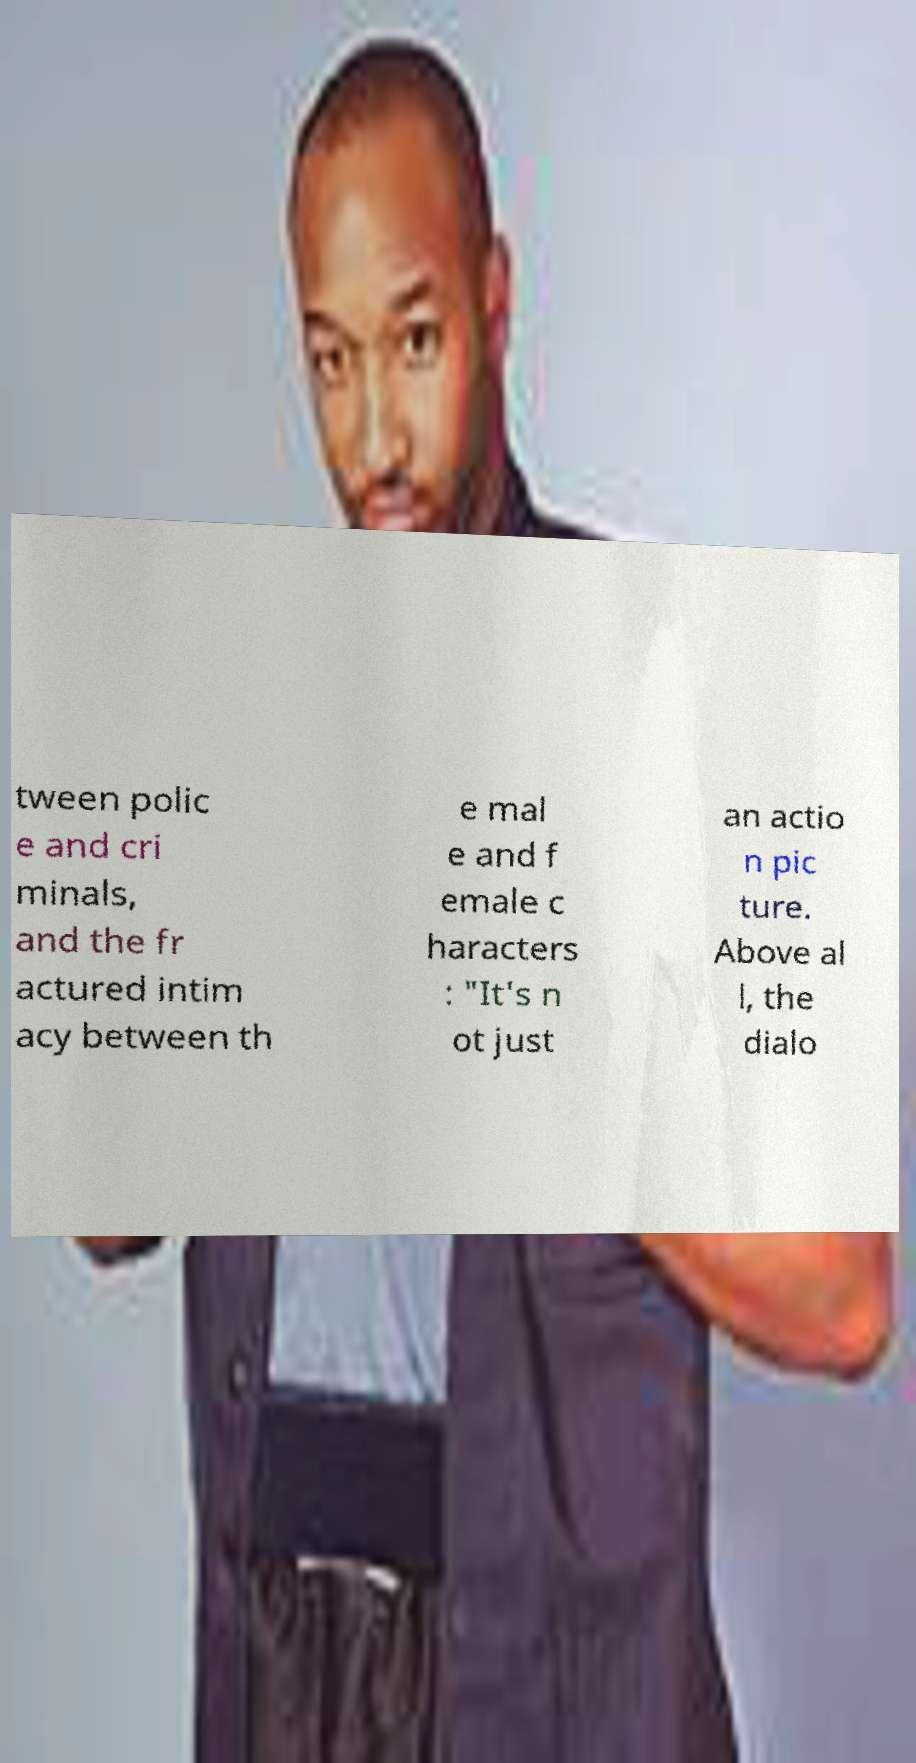Please identify and transcribe the text found in this image. tween polic e and cri minals, and the fr actured intim acy between th e mal e and f emale c haracters : "It's n ot just an actio n pic ture. Above al l, the dialo 